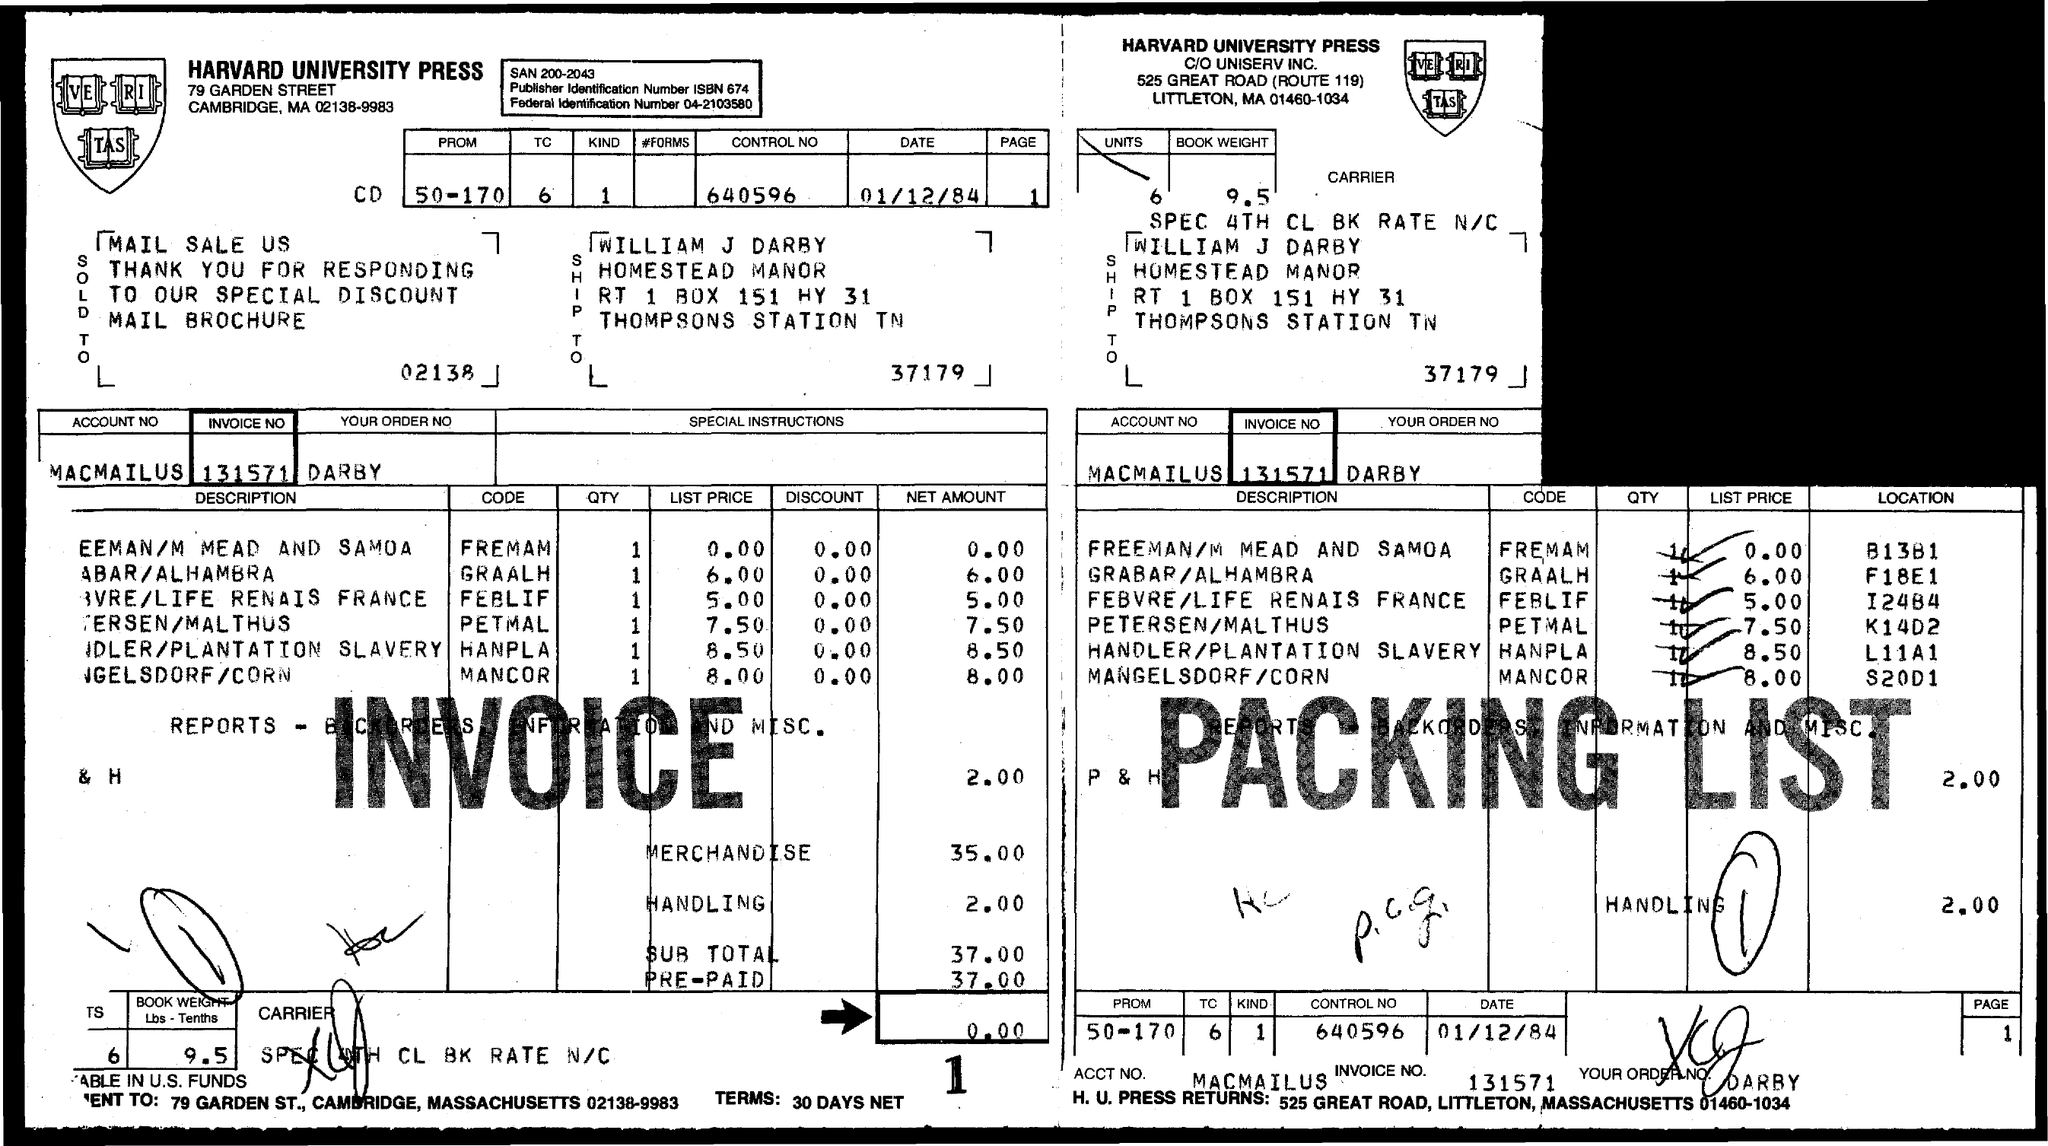What is the subtotal of invoice ?
Provide a succinct answer. 37.00. What is the invoice no?
Your answer should be compact. 131571. 